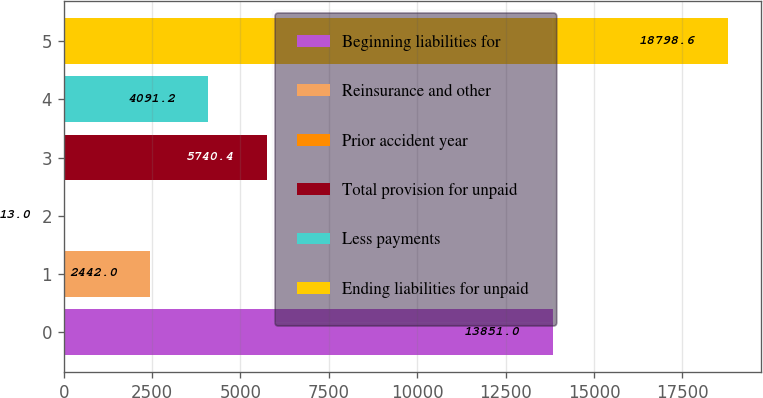Convert chart. <chart><loc_0><loc_0><loc_500><loc_500><bar_chart><fcel>Beginning liabilities for<fcel>Reinsurance and other<fcel>Prior accident year<fcel>Total provision for unpaid<fcel>Less payments<fcel>Ending liabilities for unpaid<nl><fcel>13851<fcel>2442<fcel>13<fcel>5740.4<fcel>4091.2<fcel>18798.6<nl></chart> 